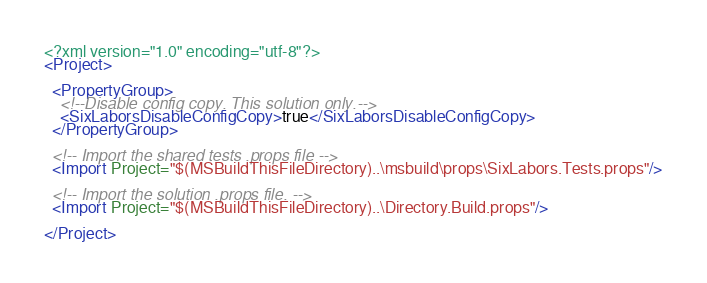Convert code to text. <code><loc_0><loc_0><loc_500><loc_500><_XML_><?xml version="1.0" encoding="utf-8"?>
<Project>

  <PropertyGroup>
    <!--Disable config copy. This solution only.-->
    <SixLaborsDisableConfigCopy>true</SixLaborsDisableConfigCopy>
  </PropertyGroup>

  <!-- Import the shared tests .props file -->
  <Import Project="$(MSBuildThisFileDirectory)..\msbuild\props\SixLabors.Tests.props"/>
  
  <!-- Import the solution .props file. -->
  <Import Project="$(MSBuildThisFileDirectory)..\Directory.Build.props"/>

</Project>
</code> 